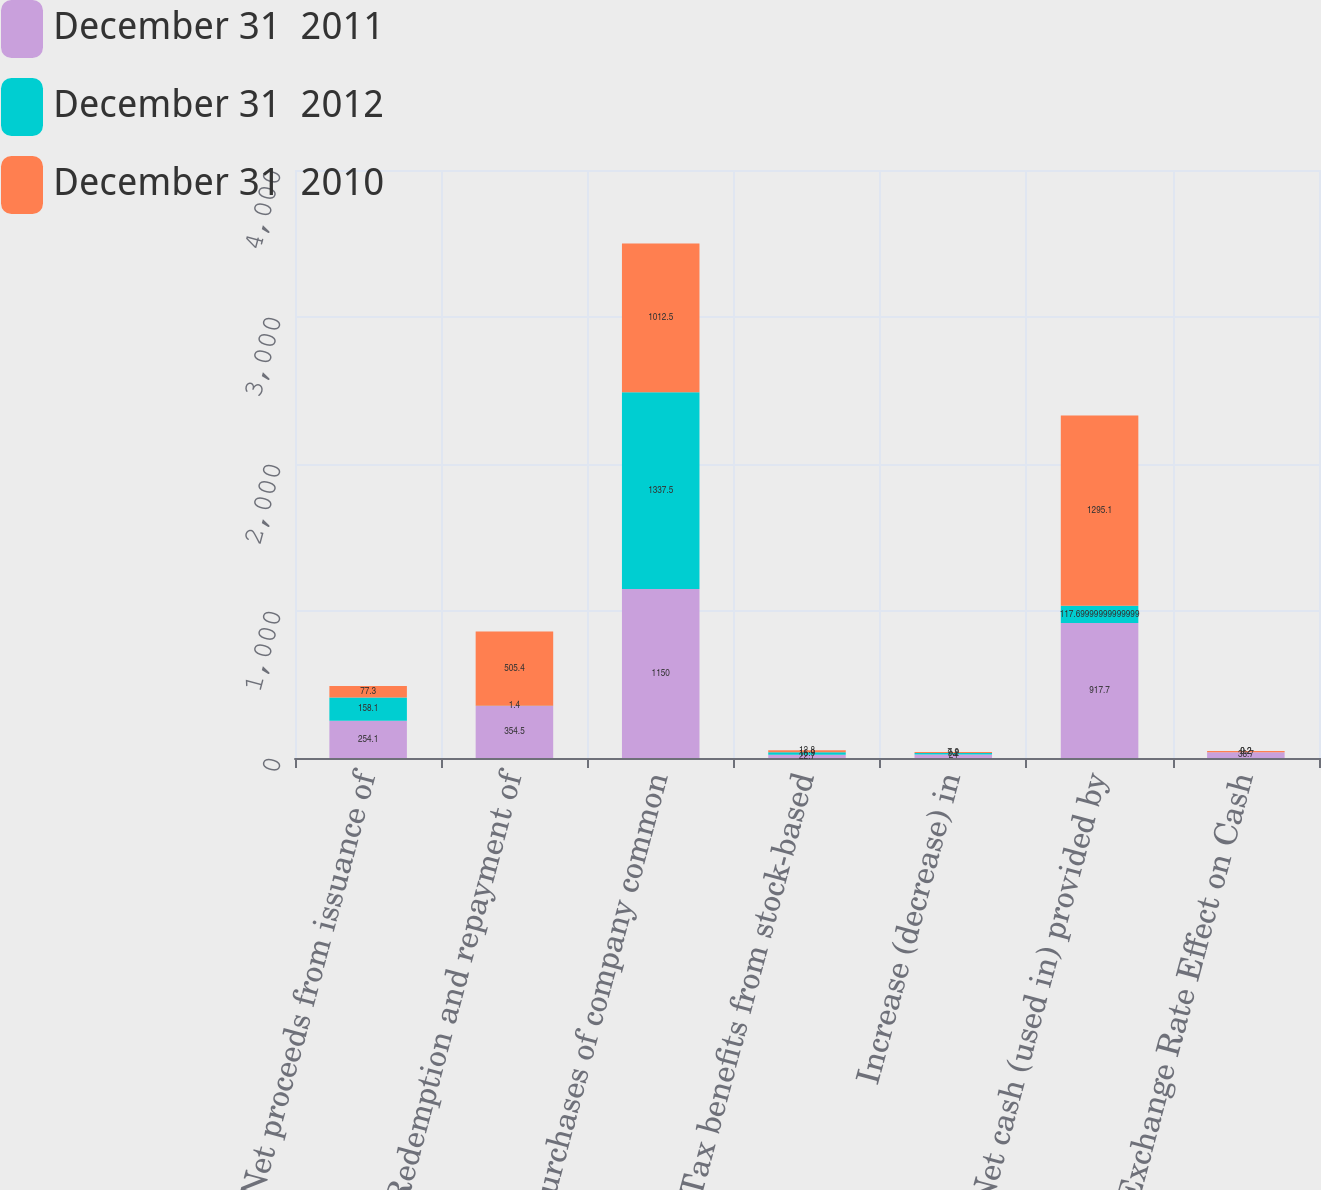Convert chart. <chart><loc_0><loc_0><loc_500><loc_500><stacked_bar_chart><ecel><fcel>Net proceeds from issuance of<fcel>Redemption and repayment of<fcel>Purchases of company common<fcel>Tax benefits from stock-based<fcel>Increase (decrease) in<fcel>Net cash (used in) provided by<fcel>Exchange Rate Effect on Cash<nl><fcel>December 31  2011<fcel>254.1<fcel>354.5<fcel>1150<fcel>22.7<fcel>24<fcel>917.7<fcel>38.7<nl><fcel>December 31  2012<fcel>158.1<fcel>1.4<fcel>1337.5<fcel>16.9<fcel>9.2<fcel>117.7<fcel>0.2<nl><fcel>December 31  2010<fcel>77.3<fcel>505.4<fcel>1012.5<fcel>12.8<fcel>7.9<fcel>1295.1<fcel>9.2<nl></chart> 